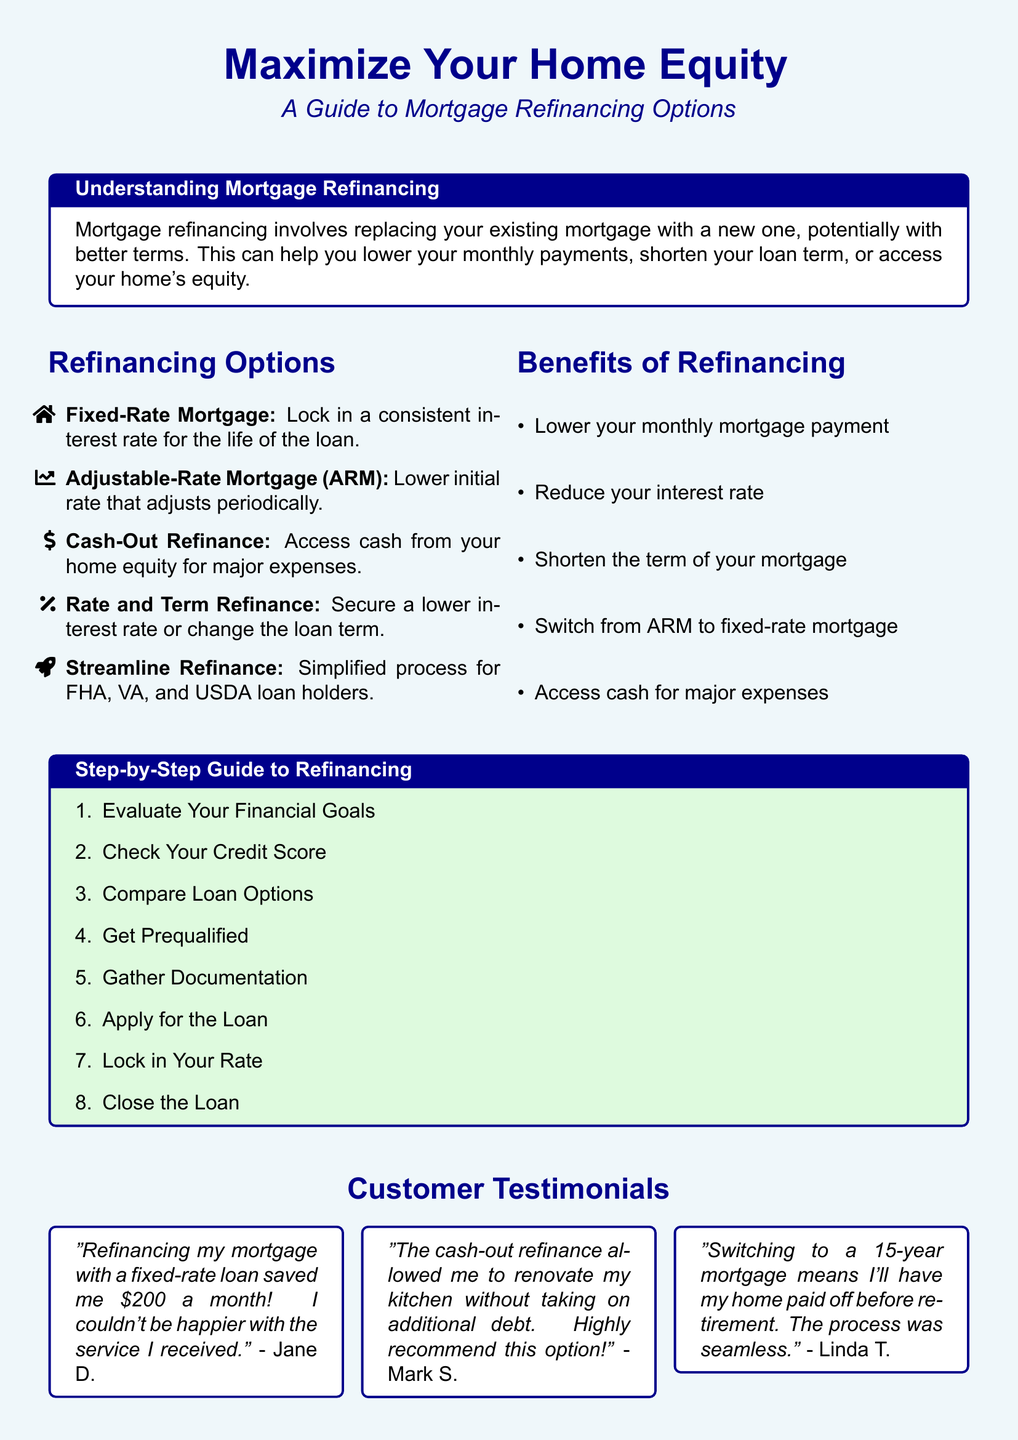What are the five refinancing options listed? The document outlines five refinancing options: Fixed-Rate Mortgage, Adjustable-Rate Mortgage, Cash-Out Refinance, Rate and Term Refinance, and Streamline Refinance.
Answer: Fixed-Rate Mortgage, Adjustable-Rate Mortgage, Cash-Out Refinance, Rate and Term Refinance, Streamline Refinance What is one benefit of refinancing? The flyer lists several benefits of refinancing, including lowering monthly mortgage payments and reducing interest rates.
Answer: Lower your monthly mortgage payment What is the first step in the step-by-step guide? The document details steps for refinancing, beginning with evaluating one's financial goals.
Answer: Evaluate Your Financial Goals Who provided a testimonial about saving $200 a month? Jane D. is the customer who shared that refinancing saved her $200 a month.
Answer: Jane D How many testimonials are included in the flyer? The flyer features three customer testimonials showcasing their positive experiences with mortgage refinancing.
Answer: Three What type of loan holders can benefit from a streamline refinance? The document mentions that streamline refinance is beneficial for specific loan holders, namely FHA, VA, and USDA.
Answer: FHA, VA, and USDA What is the color theme of the flyer? The flyer uses light blue for the background and dark blue for the main text, creating an inviting color scheme.
Answer: Light blue and dark blue What is the purpose of the document? The main purpose of the flyer is to inform readers about mortgage refinancing options and their benefits.
Answer: To inform about mortgage refinancing options 